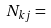Convert formula to latex. <formula><loc_0><loc_0><loc_500><loc_500>N _ { k j } =</formula> 